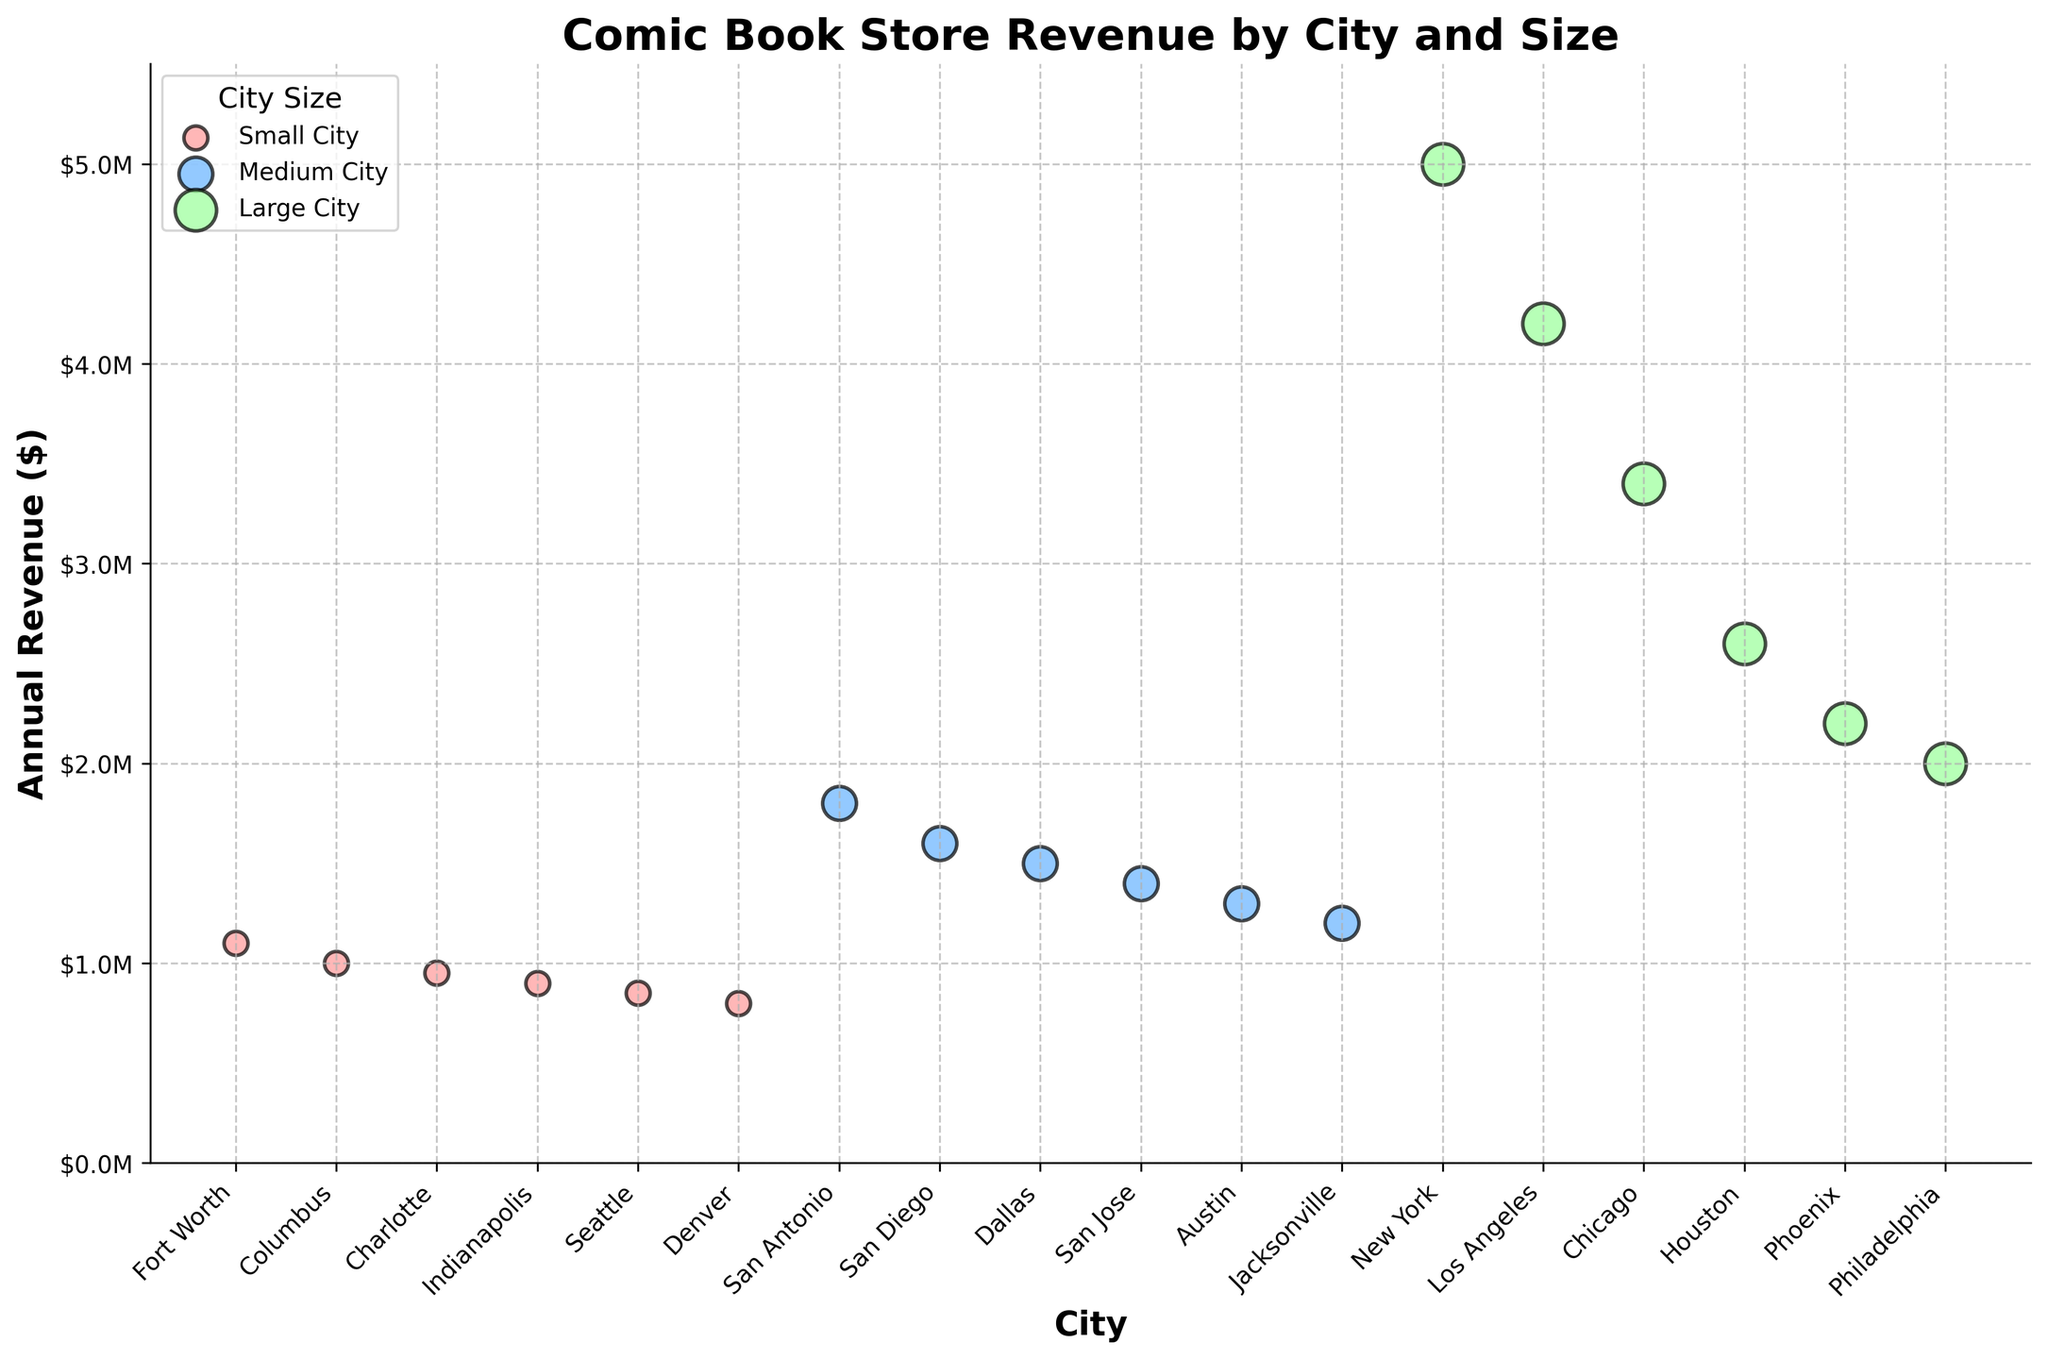What is the title of the scatter plot? The title is at the top of the figure and describes the overall content of the plot.
Answer: Comic Book Store Revenue by City and Size What is the annual revenue of Midtown Comics in New York? Look for New York City on the x-axis and find the corresponding data point. The y-axis value represents the annual revenue.
Answer: $5,000,000 Which city has the highest annual revenue for comic book stores, and what is that revenue? Find the data point that is positioned highest along the y-axis. The corresponding city is displayed on the x-axis, and the y-axis value shows the annual revenue.
Answer: New York, $5,000,000 How many Large-sized cities are represented in the scatter plot? Identify the color representing Large-sized cities in the legend and count the number of data points in that color on the plot.
Answer: 6 Which city has the lowest annual revenue, and what is that revenue? Find the data point that is positioned lowest along the y-axis. The corresponding city is displayed on the x-axis, and the y-axis value shows the annual revenue.
Answer: Denver, $800,000 What is the total annual revenue for all Medium-sized city stores combined? Identify the color representing Medium-sized cities in the legend. Sum the annual revenue values (y-axis) for all Medium-sized city data points.
Answer: $8,800,000 Compare the annual revenues of Golden Apple Comics in Los Angeles and Challengers Comics in Chicago. Which store has higher revenue and by how much? Identify the data points for Los Angeles and Chicago and note their y-axis values. Subtract the smaller value from the larger one to find the difference.
Answer: Los Angeles has $800,000 more revenue What is the average annual revenue for comic book stores in Small-sized cities? Identify the color representing Small-sized cities in the legend. Sum the annual revenue values (y-axis) for all Small-sized city data points and divide by the number of these cities.
Answer: $931,250 Which Medium-sized city has the highest annual revenue, and what is that revenue? Find the Medium-sized city data point that is positioned highest along the y-axis. The corresponding city is displayed on the x-axis, and the y-axis value shows the annual revenue.
Answer: San Antonio, $1,800,000 How many comic book stores have an annual revenue of over $2,000,000? Count the number of data points that are above the $2,000,000 mark on the y-axis.
Answer: 6 